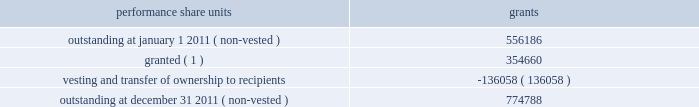During the year ended december 31 , 2011 , we granted 354660 performance share units having a fair value based on our grant date closing stock price of $ 28.79 .
These units are payable in stock and are subject to certain financial performance criteria .
The fair value of these performance share unit awards is based on the grant date closing stock price of each respective award grant and will apply to the number of units ultimately awarded .
The number of shares ultimately issued for each award will be based on our financial performance as compared to peer group companies over the performance period and can range from zero to 200% ( 200 % ) .
As of december 31 , 2011 , estimated share payouts for outstanding non-vested performance share unit awards ranged from 150% ( 150 % ) to 195% ( 195 % ) .
For the legacy frontier performance share units assumed at july 1 , 2011 , performance is based on market performance criteria , which is calculated as the total shareholder return achieved by hollyfrontier stockholders compared with the average shareholder return achieved by an equally-weighted peer group of independent refining companies over a three-year period .
These share unit awards are payable in stock based on share price performance relative to the defined peer group and can range from zero to 125% ( 125 % ) of the initial target award .
These performance share units were valued at july 1 , 2011 using a monte carlo valuation model , which simulates future stock price movements using key inputs including grant date and measurement date stock prices , expected stock price performance , expected rate of return and volatility of our stock price relative to the peer group over the three-year performance period .
The fair value of these performance share units at july 1 , 2011 was $ 8.6 million .
Of this amount , $ 7.3 million relates to post-merger services and will be recognized ratably over the remaining service period through 2013 .
A summary of performance share unit activity and changes during the year ended december 31 , 2011 is presented below: .
( 1 ) includes 225116 non-vested performance share grants under the legacy frontier plan that were outstanding and retained by hollyfrontier at july 1 , 2011 .
For the year ended december 31 , 2011 we issued 178148 shares of our common stock having a fair value of $ 2.6 million related to vested performance share units .
Based on the weighted average grant date fair value of $ 20.71 there was $ 11.7 million of total unrecognized compensation cost related to non-vested performance share units .
That cost is expected to be recognized over a weighted-average period of 1.1 years .
Note 7 : cash and cash equivalents and investments in marketable securities our investment portfolio at december 31 , 2011 consisted of cash , cash equivalents and investments in debt securities primarily issued by government and municipal entities .
We also hold 1000000 shares of connacher oil and gas limited common stock that was received as partial consideration upon the sale of our montana refinery in we invest in highly-rated marketable debt securities , primarily issued by government and municipal entities that have maturities at the date of purchase of greater than three months .
We also invest in other marketable debt securities with the maximum maturity or put date of any individual issue generally not greater than two years from the date of purchase .
All of these instruments , including investments in equity securities , are classified as available- for-sale .
As a result , they are reported at fair value using quoted market prices .
Interest income is recorded as earned .
Unrealized gains and losses , net of related income taxes , are reported as a component of accumulated other comprehensive income .
Upon sale , realized gains and losses on the sale of marketable securities are computed based on the specific identification of the underlying cost of the securities sold and the unrealized gains and losses previously reported in other comprehensive income are reclassified to current earnings. .
What percentage of july 2011 performance shares does not relate to post-merger services? 
Computations: ((8.6 - 7.3) / 8.6)
Answer: 0.15116. During the year ended december 31 , 2011 , we granted 354660 performance share units having a fair value based on our grant date closing stock price of $ 28.79 .
These units are payable in stock and are subject to certain financial performance criteria .
The fair value of these performance share unit awards is based on the grant date closing stock price of each respective award grant and will apply to the number of units ultimately awarded .
The number of shares ultimately issued for each award will be based on our financial performance as compared to peer group companies over the performance period and can range from zero to 200% ( 200 % ) .
As of december 31 , 2011 , estimated share payouts for outstanding non-vested performance share unit awards ranged from 150% ( 150 % ) to 195% ( 195 % ) .
For the legacy frontier performance share units assumed at july 1 , 2011 , performance is based on market performance criteria , which is calculated as the total shareholder return achieved by hollyfrontier stockholders compared with the average shareholder return achieved by an equally-weighted peer group of independent refining companies over a three-year period .
These share unit awards are payable in stock based on share price performance relative to the defined peer group and can range from zero to 125% ( 125 % ) of the initial target award .
These performance share units were valued at july 1 , 2011 using a monte carlo valuation model , which simulates future stock price movements using key inputs including grant date and measurement date stock prices , expected stock price performance , expected rate of return and volatility of our stock price relative to the peer group over the three-year performance period .
The fair value of these performance share units at july 1 , 2011 was $ 8.6 million .
Of this amount , $ 7.3 million relates to post-merger services and will be recognized ratably over the remaining service period through 2013 .
A summary of performance share unit activity and changes during the year ended december 31 , 2011 is presented below: .
( 1 ) includes 225116 non-vested performance share grants under the legacy frontier plan that were outstanding and retained by hollyfrontier at july 1 , 2011 .
For the year ended december 31 , 2011 we issued 178148 shares of our common stock having a fair value of $ 2.6 million related to vested performance share units .
Based on the weighted average grant date fair value of $ 20.71 there was $ 11.7 million of total unrecognized compensation cost related to non-vested performance share units .
That cost is expected to be recognized over a weighted-average period of 1.1 years .
Note 7 : cash and cash equivalents and investments in marketable securities our investment portfolio at december 31 , 2011 consisted of cash , cash equivalents and investments in debt securities primarily issued by government and municipal entities .
We also hold 1000000 shares of connacher oil and gas limited common stock that was received as partial consideration upon the sale of our montana refinery in we invest in highly-rated marketable debt securities , primarily issued by government and municipal entities that have maturities at the date of purchase of greater than three months .
We also invest in other marketable debt securities with the maximum maturity or put date of any individual issue generally not greater than two years from the date of purchase .
All of these instruments , including investments in equity securities , are classified as available- for-sale .
As a result , they are reported at fair value using quoted market prices .
Interest income is recorded as earned .
Unrealized gains and losses , net of related income taxes , are reported as a component of accumulated other comprehensive income .
Upon sale , realized gains and losses on the sale of marketable securities are computed based on the specific identification of the underlying cost of the securities sold and the unrealized gains and losses previously reported in other comprehensive income are reclassified to current earnings. .
For performance share units , without the grants during the year , what would be the balance in shares outstanding at december 31 2011 ( non-vested ) ? 
Computations: (774788 - 354660)
Answer: 420128.0. During the year ended december 31 , 2011 , we granted 354660 performance share units having a fair value based on our grant date closing stock price of $ 28.79 .
These units are payable in stock and are subject to certain financial performance criteria .
The fair value of these performance share unit awards is based on the grant date closing stock price of each respective award grant and will apply to the number of units ultimately awarded .
The number of shares ultimately issued for each award will be based on our financial performance as compared to peer group companies over the performance period and can range from zero to 200% ( 200 % ) .
As of december 31 , 2011 , estimated share payouts for outstanding non-vested performance share unit awards ranged from 150% ( 150 % ) to 195% ( 195 % ) .
For the legacy frontier performance share units assumed at july 1 , 2011 , performance is based on market performance criteria , which is calculated as the total shareholder return achieved by hollyfrontier stockholders compared with the average shareholder return achieved by an equally-weighted peer group of independent refining companies over a three-year period .
These share unit awards are payable in stock based on share price performance relative to the defined peer group and can range from zero to 125% ( 125 % ) of the initial target award .
These performance share units were valued at july 1 , 2011 using a monte carlo valuation model , which simulates future stock price movements using key inputs including grant date and measurement date stock prices , expected stock price performance , expected rate of return and volatility of our stock price relative to the peer group over the three-year performance period .
The fair value of these performance share units at july 1 , 2011 was $ 8.6 million .
Of this amount , $ 7.3 million relates to post-merger services and will be recognized ratably over the remaining service period through 2013 .
A summary of performance share unit activity and changes during the year ended december 31 , 2011 is presented below: .
( 1 ) includes 225116 non-vested performance share grants under the legacy frontier plan that were outstanding and retained by hollyfrontier at july 1 , 2011 .
For the year ended december 31 , 2011 we issued 178148 shares of our common stock having a fair value of $ 2.6 million related to vested performance share units .
Based on the weighted average grant date fair value of $ 20.71 there was $ 11.7 million of total unrecognized compensation cost related to non-vested performance share units .
That cost is expected to be recognized over a weighted-average period of 1.1 years .
Note 7 : cash and cash equivalents and investments in marketable securities our investment portfolio at december 31 , 2011 consisted of cash , cash equivalents and investments in debt securities primarily issued by government and municipal entities .
We also hold 1000000 shares of connacher oil and gas limited common stock that was received as partial consideration upon the sale of our montana refinery in we invest in highly-rated marketable debt securities , primarily issued by government and municipal entities that have maturities at the date of purchase of greater than three months .
We also invest in other marketable debt securities with the maximum maturity or put date of any individual issue generally not greater than two years from the date of purchase .
All of these instruments , including investments in equity securities , are classified as available- for-sale .
As a result , they are reported at fair value using quoted market prices .
Interest income is recorded as earned .
Unrealized gains and losses , net of related income taxes , are reported as a component of accumulated other comprehensive income .
Upon sale , realized gains and losses on the sale of marketable securities are computed based on the specific identification of the underlying cost of the securities sold and the unrealized gains and losses previously reported in other comprehensive income are reclassified to current earnings. .
In 2011 what was the percent of the shares granted under the legacy frontier plan in july? 
Computations: (225116 / 354660)
Answer: 0.63474. During the year ended december 31 , 2011 , we granted 354660 performance share units having a fair value based on our grant date closing stock price of $ 28.79 .
These units are payable in stock and are subject to certain financial performance criteria .
The fair value of these performance share unit awards is based on the grant date closing stock price of each respective award grant and will apply to the number of units ultimately awarded .
The number of shares ultimately issued for each award will be based on our financial performance as compared to peer group companies over the performance period and can range from zero to 200% ( 200 % ) .
As of december 31 , 2011 , estimated share payouts for outstanding non-vested performance share unit awards ranged from 150% ( 150 % ) to 195% ( 195 % ) .
For the legacy frontier performance share units assumed at july 1 , 2011 , performance is based on market performance criteria , which is calculated as the total shareholder return achieved by hollyfrontier stockholders compared with the average shareholder return achieved by an equally-weighted peer group of independent refining companies over a three-year period .
These share unit awards are payable in stock based on share price performance relative to the defined peer group and can range from zero to 125% ( 125 % ) of the initial target award .
These performance share units were valued at july 1 , 2011 using a monte carlo valuation model , which simulates future stock price movements using key inputs including grant date and measurement date stock prices , expected stock price performance , expected rate of return and volatility of our stock price relative to the peer group over the three-year performance period .
The fair value of these performance share units at july 1 , 2011 was $ 8.6 million .
Of this amount , $ 7.3 million relates to post-merger services and will be recognized ratably over the remaining service period through 2013 .
A summary of performance share unit activity and changes during the year ended december 31 , 2011 is presented below: .
( 1 ) includes 225116 non-vested performance share grants under the legacy frontier plan that were outstanding and retained by hollyfrontier at july 1 , 2011 .
For the year ended december 31 , 2011 we issued 178148 shares of our common stock having a fair value of $ 2.6 million related to vested performance share units .
Based on the weighted average grant date fair value of $ 20.71 there was $ 11.7 million of total unrecognized compensation cost related to non-vested performance share units .
That cost is expected to be recognized over a weighted-average period of 1.1 years .
Note 7 : cash and cash equivalents and investments in marketable securities our investment portfolio at december 31 , 2011 consisted of cash , cash equivalents and investments in debt securities primarily issued by government and municipal entities .
We also hold 1000000 shares of connacher oil and gas limited common stock that was received as partial consideration upon the sale of our montana refinery in we invest in highly-rated marketable debt securities , primarily issued by government and municipal entities that have maturities at the date of purchase of greater than three months .
We also invest in other marketable debt securities with the maximum maturity or put date of any individual issue generally not greater than two years from the date of purchase .
All of these instruments , including investments in equity securities , are classified as available- for-sale .
As a result , they are reported at fair value using quoted market prices .
Interest income is recorded as earned .
Unrealized gains and losses , net of related income taxes , are reported as a component of accumulated other comprehensive income .
Upon sale , realized gains and losses on the sale of marketable securities are computed based on the specific identification of the underlying cost of the securities sold and the unrealized gains and losses previously reported in other comprehensive income are reclassified to current earnings. .
In 2011 what was the percent of the change in the performance shares outstanding? 
Computations: ((774788 - 556186) / 556186)
Answer: 0.39304. 